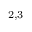Convert formula to latex. <formula><loc_0><loc_0><loc_500><loc_500>^ { 2 , 3 }</formula> 